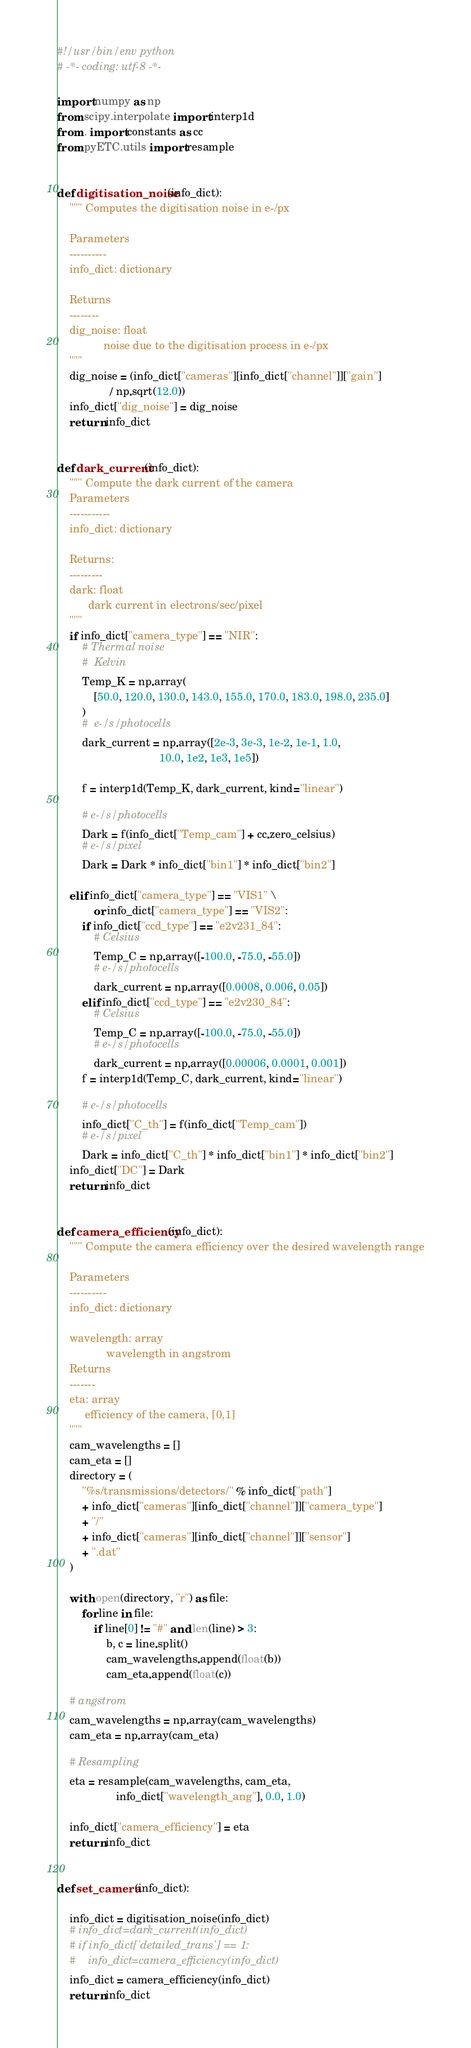Convert code to text. <code><loc_0><loc_0><loc_500><loc_500><_Python_>#!/usr/bin/env python
# -*- coding: utf-8 -*-

import numpy as np
from scipy.interpolate import interp1d
from . import constants as cc
from pyETC.utils import resample


def digitisation_noise(info_dict):
    """ Computes the digitisation noise in e-/px

    Parameters
    ----------
    info_dict: dictionary

    Returns
    --------
    dig_noise: float
               noise due to the digitisation process in e-/px
    """
    dig_noise = (info_dict["cameras"][info_dict["channel"]]["gain"]
                 / np.sqrt(12.0))
    info_dict["dig_noise"] = dig_noise
    return info_dict


def dark_current(info_dict):
    """ Compute the dark current of the camera
    Parameters
    -----------
    info_dict: dictionary

    Returns:
    ---------
    dark: float
          dark current in electrons/sec/pixel
    """
    if info_dict["camera_type"] == "NIR":
        # Thermal noise
        #  Kelvin
        Temp_K = np.array(
            [50.0, 120.0, 130.0, 143.0, 155.0, 170.0, 183.0, 198.0, 235.0]
        )
        #  e-/s/photocells
        dark_current = np.array([2e-3, 3e-3, 1e-2, 1e-1, 1.0,
                                 10.0, 1e2, 1e3, 1e5])

        f = interp1d(Temp_K, dark_current, kind="linear")

        # e-/s/photocells
        Dark = f(info_dict["Temp_cam"] + cc.zero_celsius)
        # e-/s/pixel
        Dark = Dark * info_dict["bin1"] * info_dict["bin2"]

    elif info_dict["camera_type"] == "VIS1" \
            or info_dict["camera_type"] == "VIS2":
        if info_dict["ccd_type"] == "e2v231_84":
            # Celsius
            Temp_C = np.array([-100.0, -75.0, -55.0])
            # e-/s/photocells
            dark_current = np.array([0.0008, 0.006, 0.05])
        elif info_dict["ccd_type"] == "e2v230_84":
            # Celsius
            Temp_C = np.array([-100.0, -75.0, -55.0])
            # e-/s/photocells
            dark_current = np.array([0.00006, 0.0001, 0.001])
        f = interp1d(Temp_C, dark_current, kind="linear")

        # e-/s/photocells
        info_dict["C_th"] = f(info_dict["Temp_cam"])
        # e-/s/pixel
        Dark = info_dict["C_th"] * info_dict["bin1"] * info_dict["bin2"]
    info_dict["DC"] = Dark
    return info_dict


def camera_efficiency(info_dict):
    """ Compute the camera efficiency over the desired wavelength range

    Parameters
    ----------
    info_dict: dictionary

    wavelength: array
                wavelength in angstrom
    Returns
    -------
    eta: array
         efficiency of the camera, [0,1]
    """
    cam_wavelengths = []
    cam_eta = []
    directory = (
        "%s/transmissions/detectors/" % info_dict["path"]
        + info_dict["cameras"][info_dict["channel"]]["camera_type"]
        + "/"
        + info_dict["cameras"][info_dict["channel"]]["sensor"]
        + ".dat"
    )

    with open(directory, "r") as file:
        for line in file:
            if line[0] != "#" and len(line) > 3:
                b, c = line.split()
                cam_wavelengths.append(float(b))
                cam_eta.append(float(c))

    # angstrom
    cam_wavelengths = np.array(cam_wavelengths)
    cam_eta = np.array(cam_eta)

    # Resampling
    eta = resample(cam_wavelengths, cam_eta,
                   info_dict["wavelength_ang"], 0.0, 1.0)

    info_dict["camera_efficiency"] = eta
    return info_dict


def set_camera(info_dict):

    info_dict = digitisation_noise(info_dict)
    # info_dict=dark_current(info_dict)
    # if info_dict['detailed_trans'] == 1:
    #    info_dict=camera_efficiency(info_dict)
    info_dict = camera_efficiency(info_dict)
    return info_dict
</code> 